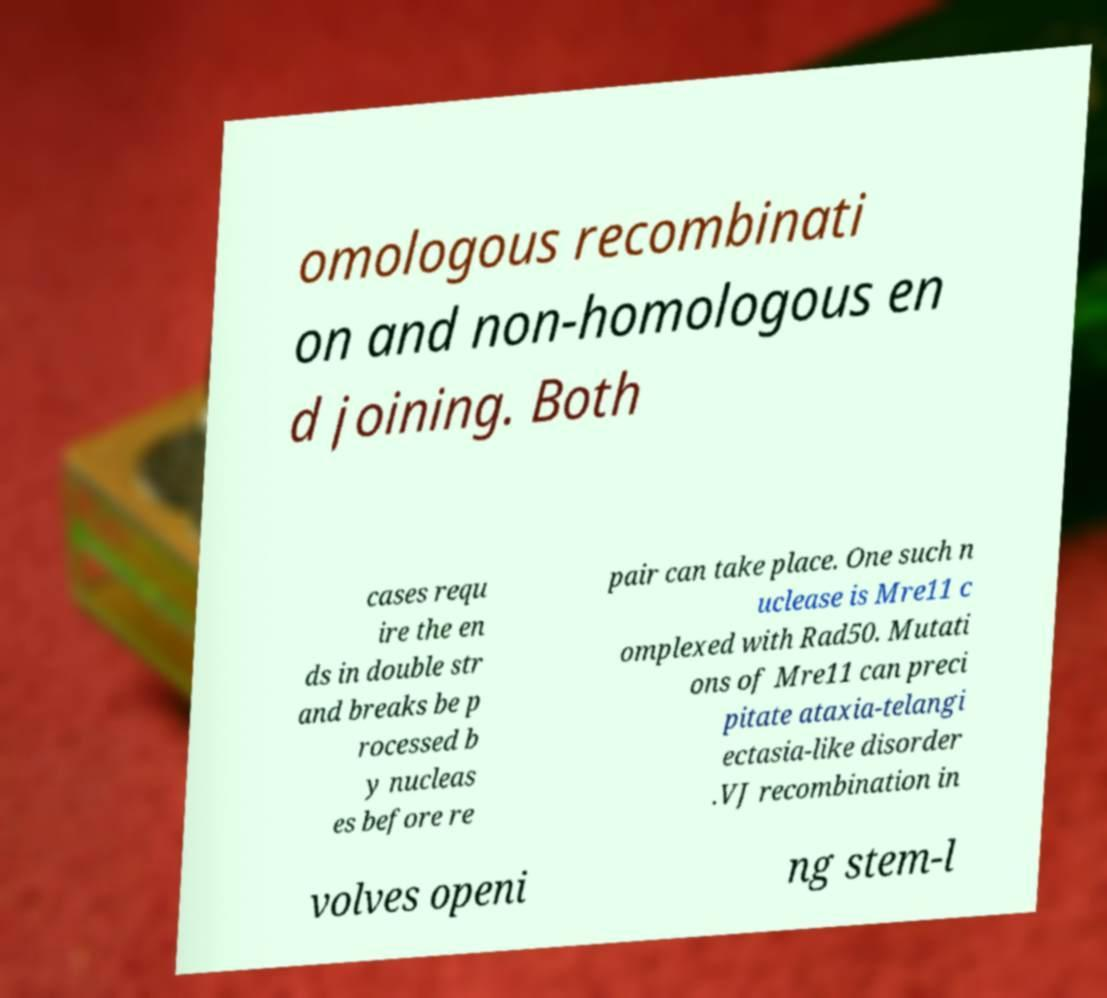Please identify and transcribe the text found in this image. omologous recombinati on and non-homologous en d joining. Both cases requ ire the en ds in double str and breaks be p rocessed b y nucleas es before re pair can take place. One such n uclease is Mre11 c omplexed with Rad50. Mutati ons of Mre11 can preci pitate ataxia-telangi ectasia-like disorder .VJ recombination in volves openi ng stem-l 